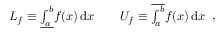<formula> <loc_0><loc_0><loc_500><loc_500>{ \begin{array} { r l } { L _ { f } \equiv \underline { { \int _ { a } ^ { b } } } f ( x ) \, d x } & \quad U _ { f } \equiv \overline { { \int _ { a } ^ { b } } } f ( x ) \, d x } \end{array} } ,</formula> 